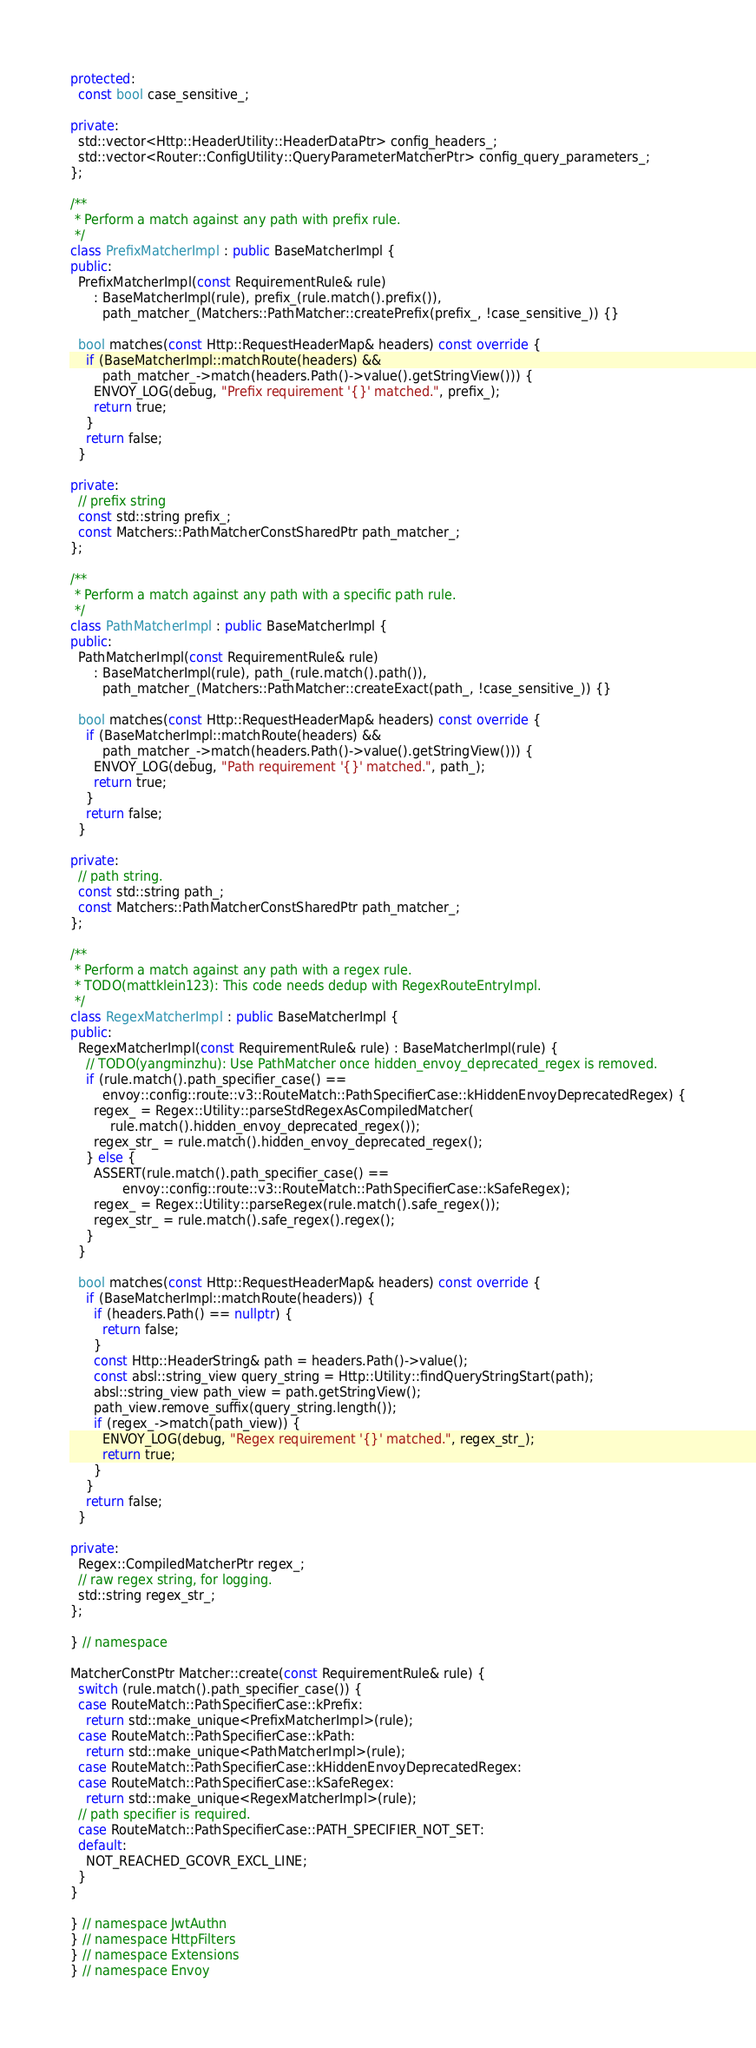Convert code to text. <code><loc_0><loc_0><loc_500><loc_500><_C++_>protected:
  const bool case_sensitive_;

private:
  std::vector<Http::HeaderUtility::HeaderDataPtr> config_headers_;
  std::vector<Router::ConfigUtility::QueryParameterMatcherPtr> config_query_parameters_;
};

/**
 * Perform a match against any path with prefix rule.
 */
class PrefixMatcherImpl : public BaseMatcherImpl {
public:
  PrefixMatcherImpl(const RequirementRule& rule)
      : BaseMatcherImpl(rule), prefix_(rule.match().prefix()),
        path_matcher_(Matchers::PathMatcher::createPrefix(prefix_, !case_sensitive_)) {}

  bool matches(const Http::RequestHeaderMap& headers) const override {
    if (BaseMatcherImpl::matchRoute(headers) &&
        path_matcher_->match(headers.Path()->value().getStringView())) {
      ENVOY_LOG(debug, "Prefix requirement '{}' matched.", prefix_);
      return true;
    }
    return false;
  }

private:
  // prefix string
  const std::string prefix_;
  const Matchers::PathMatcherConstSharedPtr path_matcher_;
};

/**
 * Perform a match against any path with a specific path rule.
 */
class PathMatcherImpl : public BaseMatcherImpl {
public:
  PathMatcherImpl(const RequirementRule& rule)
      : BaseMatcherImpl(rule), path_(rule.match().path()),
        path_matcher_(Matchers::PathMatcher::createExact(path_, !case_sensitive_)) {}

  bool matches(const Http::RequestHeaderMap& headers) const override {
    if (BaseMatcherImpl::matchRoute(headers) &&
        path_matcher_->match(headers.Path()->value().getStringView())) {
      ENVOY_LOG(debug, "Path requirement '{}' matched.", path_);
      return true;
    }
    return false;
  }

private:
  // path string.
  const std::string path_;
  const Matchers::PathMatcherConstSharedPtr path_matcher_;
};

/**
 * Perform a match against any path with a regex rule.
 * TODO(mattklein123): This code needs dedup with RegexRouteEntryImpl.
 */
class RegexMatcherImpl : public BaseMatcherImpl {
public:
  RegexMatcherImpl(const RequirementRule& rule) : BaseMatcherImpl(rule) {
    // TODO(yangminzhu): Use PathMatcher once hidden_envoy_deprecated_regex is removed.
    if (rule.match().path_specifier_case() ==
        envoy::config::route::v3::RouteMatch::PathSpecifierCase::kHiddenEnvoyDeprecatedRegex) {
      regex_ = Regex::Utility::parseStdRegexAsCompiledMatcher(
          rule.match().hidden_envoy_deprecated_regex());
      regex_str_ = rule.match().hidden_envoy_deprecated_regex();
    } else {
      ASSERT(rule.match().path_specifier_case() ==
             envoy::config::route::v3::RouteMatch::PathSpecifierCase::kSafeRegex);
      regex_ = Regex::Utility::parseRegex(rule.match().safe_regex());
      regex_str_ = rule.match().safe_regex().regex();
    }
  }

  bool matches(const Http::RequestHeaderMap& headers) const override {
    if (BaseMatcherImpl::matchRoute(headers)) {
      if (headers.Path() == nullptr) {
        return false;
      }
      const Http::HeaderString& path = headers.Path()->value();
      const absl::string_view query_string = Http::Utility::findQueryStringStart(path);
      absl::string_view path_view = path.getStringView();
      path_view.remove_suffix(query_string.length());
      if (regex_->match(path_view)) {
        ENVOY_LOG(debug, "Regex requirement '{}' matched.", regex_str_);
        return true;
      }
    }
    return false;
  }

private:
  Regex::CompiledMatcherPtr regex_;
  // raw regex string, for logging.
  std::string regex_str_;
};

} // namespace

MatcherConstPtr Matcher::create(const RequirementRule& rule) {
  switch (rule.match().path_specifier_case()) {
  case RouteMatch::PathSpecifierCase::kPrefix:
    return std::make_unique<PrefixMatcherImpl>(rule);
  case RouteMatch::PathSpecifierCase::kPath:
    return std::make_unique<PathMatcherImpl>(rule);
  case RouteMatch::PathSpecifierCase::kHiddenEnvoyDeprecatedRegex:
  case RouteMatch::PathSpecifierCase::kSafeRegex:
    return std::make_unique<RegexMatcherImpl>(rule);
  // path specifier is required.
  case RouteMatch::PathSpecifierCase::PATH_SPECIFIER_NOT_SET:
  default:
    NOT_REACHED_GCOVR_EXCL_LINE;
  }
}

} // namespace JwtAuthn
} // namespace HttpFilters
} // namespace Extensions
} // namespace Envoy
</code> 